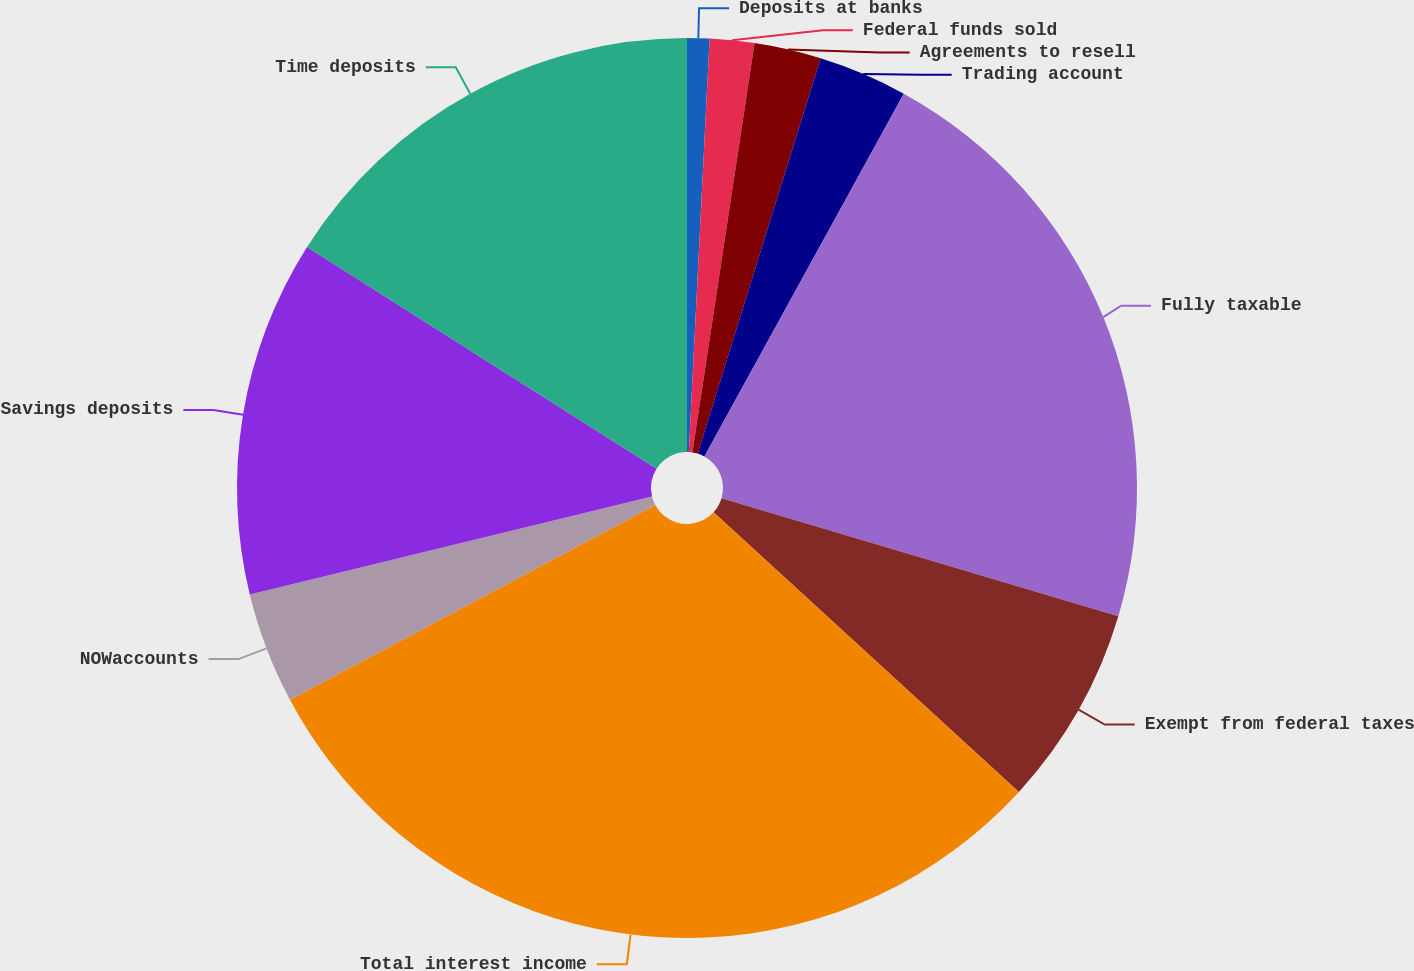Convert chart to OTSL. <chart><loc_0><loc_0><loc_500><loc_500><pie_chart><fcel>Deposits at banks<fcel>Federal funds sold<fcel>Agreements to resell<fcel>Trading account<fcel>Fully taxable<fcel>Exempt from federal taxes<fcel>Total interest income<fcel>NOWaccounts<fcel>Savings deposits<fcel>Time deposits<nl><fcel>0.8%<fcel>1.6%<fcel>2.4%<fcel>3.2%<fcel>21.6%<fcel>7.2%<fcel>30.4%<fcel>4.0%<fcel>12.8%<fcel>16.0%<nl></chart> 